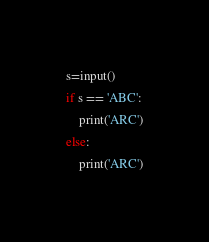<code> <loc_0><loc_0><loc_500><loc_500><_Python_>s=input()
if s == 'ABC':
    print('ARC')
else:
    print('ARC')</code> 